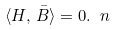<formula> <loc_0><loc_0><loc_500><loc_500>\langle H , \, \bar { B } \rangle = 0 . \ n</formula> 